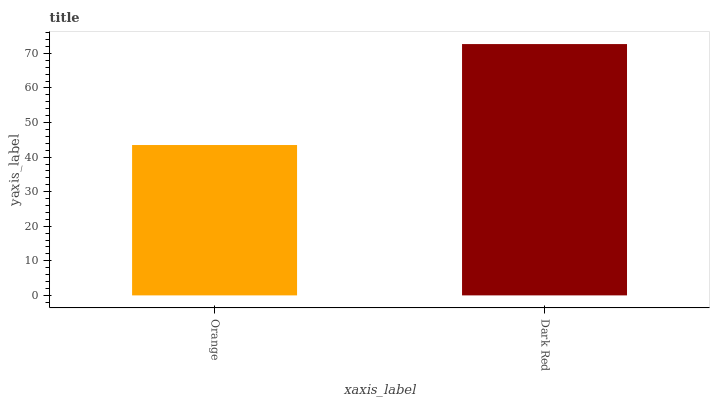Is Dark Red the minimum?
Answer yes or no. No. Is Dark Red greater than Orange?
Answer yes or no. Yes. Is Orange less than Dark Red?
Answer yes or no. Yes. Is Orange greater than Dark Red?
Answer yes or no. No. Is Dark Red less than Orange?
Answer yes or no. No. Is Dark Red the high median?
Answer yes or no. Yes. Is Orange the low median?
Answer yes or no. Yes. Is Orange the high median?
Answer yes or no. No. Is Dark Red the low median?
Answer yes or no. No. 